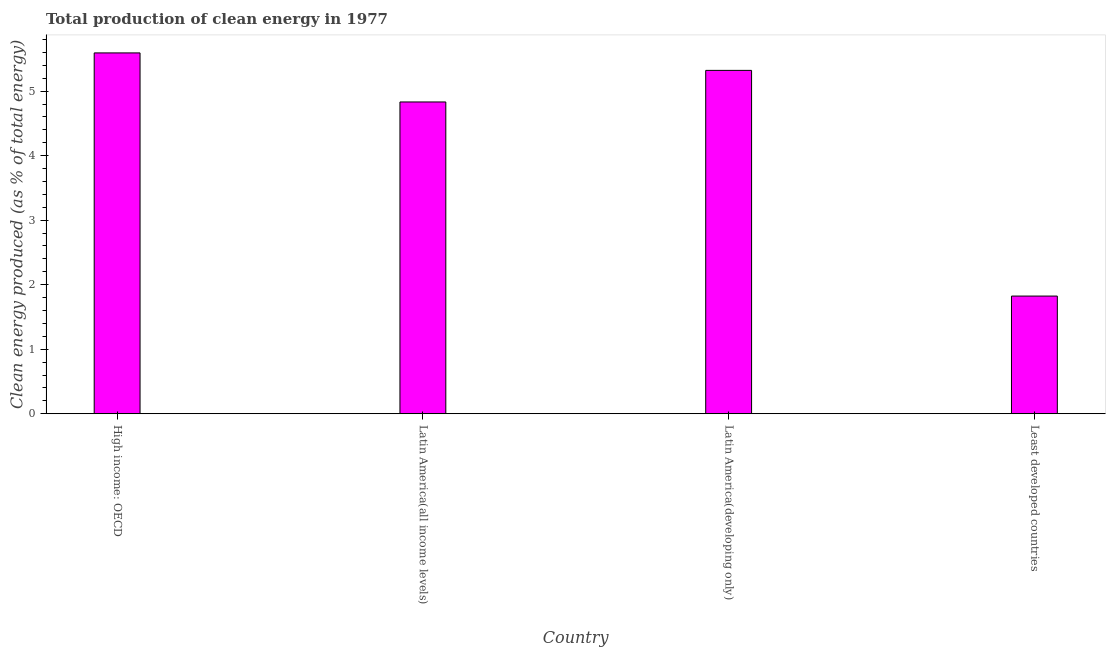Does the graph contain any zero values?
Keep it short and to the point. No. What is the title of the graph?
Offer a terse response. Total production of clean energy in 1977. What is the label or title of the Y-axis?
Your answer should be compact. Clean energy produced (as % of total energy). What is the production of clean energy in Least developed countries?
Make the answer very short. 1.82. Across all countries, what is the maximum production of clean energy?
Your answer should be very brief. 5.59. Across all countries, what is the minimum production of clean energy?
Offer a terse response. 1.82. In which country was the production of clean energy maximum?
Provide a succinct answer. High income: OECD. In which country was the production of clean energy minimum?
Keep it short and to the point. Least developed countries. What is the sum of the production of clean energy?
Your response must be concise. 17.57. What is the difference between the production of clean energy in Latin America(all income levels) and Latin America(developing only)?
Keep it short and to the point. -0.49. What is the average production of clean energy per country?
Offer a very short reply. 4.39. What is the median production of clean energy?
Keep it short and to the point. 5.08. In how many countries, is the production of clean energy greater than 4.6 %?
Make the answer very short. 3. What is the ratio of the production of clean energy in Latin America(all income levels) to that in Least developed countries?
Offer a terse response. 2.65. Is the difference between the production of clean energy in High income: OECD and Latin America(developing only) greater than the difference between any two countries?
Provide a short and direct response. No. What is the difference between the highest and the second highest production of clean energy?
Provide a succinct answer. 0.27. What is the difference between the highest and the lowest production of clean energy?
Make the answer very short. 3.77. In how many countries, is the production of clean energy greater than the average production of clean energy taken over all countries?
Provide a short and direct response. 3. How many bars are there?
Provide a short and direct response. 4. Are all the bars in the graph horizontal?
Provide a succinct answer. No. What is the difference between two consecutive major ticks on the Y-axis?
Give a very brief answer. 1. Are the values on the major ticks of Y-axis written in scientific E-notation?
Your response must be concise. No. What is the Clean energy produced (as % of total energy) in High income: OECD?
Offer a terse response. 5.59. What is the Clean energy produced (as % of total energy) in Latin America(all income levels)?
Give a very brief answer. 4.83. What is the Clean energy produced (as % of total energy) in Latin America(developing only)?
Offer a very short reply. 5.32. What is the Clean energy produced (as % of total energy) in Least developed countries?
Your response must be concise. 1.82. What is the difference between the Clean energy produced (as % of total energy) in High income: OECD and Latin America(all income levels)?
Your answer should be very brief. 0.76. What is the difference between the Clean energy produced (as % of total energy) in High income: OECD and Latin America(developing only)?
Give a very brief answer. 0.27. What is the difference between the Clean energy produced (as % of total energy) in High income: OECD and Least developed countries?
Give a very brief answer. 3.77. What is the difference between the Clean energy produced (as % of total energy) in Latin America(all income levels) and Latin America(developing only)?
Keep it short and to the point. -0.49. What is the difference between the Clean energy produced (as % of total energy) in Latin America(all income levels) and Least developed countries?
Give a very brief answer. 3.01. What is the difference between the Clean energy produced (as % of total energy) in Latin America(developing only) and Least developed countries?
Make the answer very short. 3.5. What is the ratio of the Clean energy produced (as % of total energy) in High income: OECD to that in Latin America(all income levels)?
Provide a short and direct response. 1.16. What is the ratio of the Clean energy produced (as % of total energy) in High income: OECD to that in Latin America(developing only)?
Give a very brief answer. 1.05. What is the ratio of the Clean energy produced (as % of total energy) in High income: OECD to that in Least developed countries?
Your answer should be compact. 3.07. What is the ratio of the Clean energy produced (as % of total energy) in Latin America(all income levels) to that in Latin America(developing only)?
Offer a very short reply. 0.91. What is the ratio of the Clean energy produced (as % of total energy) in Latin America(all income levels) to that in Least developed countries?
Provide a short and direct response. 2.65. What is the ratio of the Clean energy produced (as % of total energy) in Latin America(developing only) to that in Least developed countries?
Ensure brevity in your answer.  2.92. 